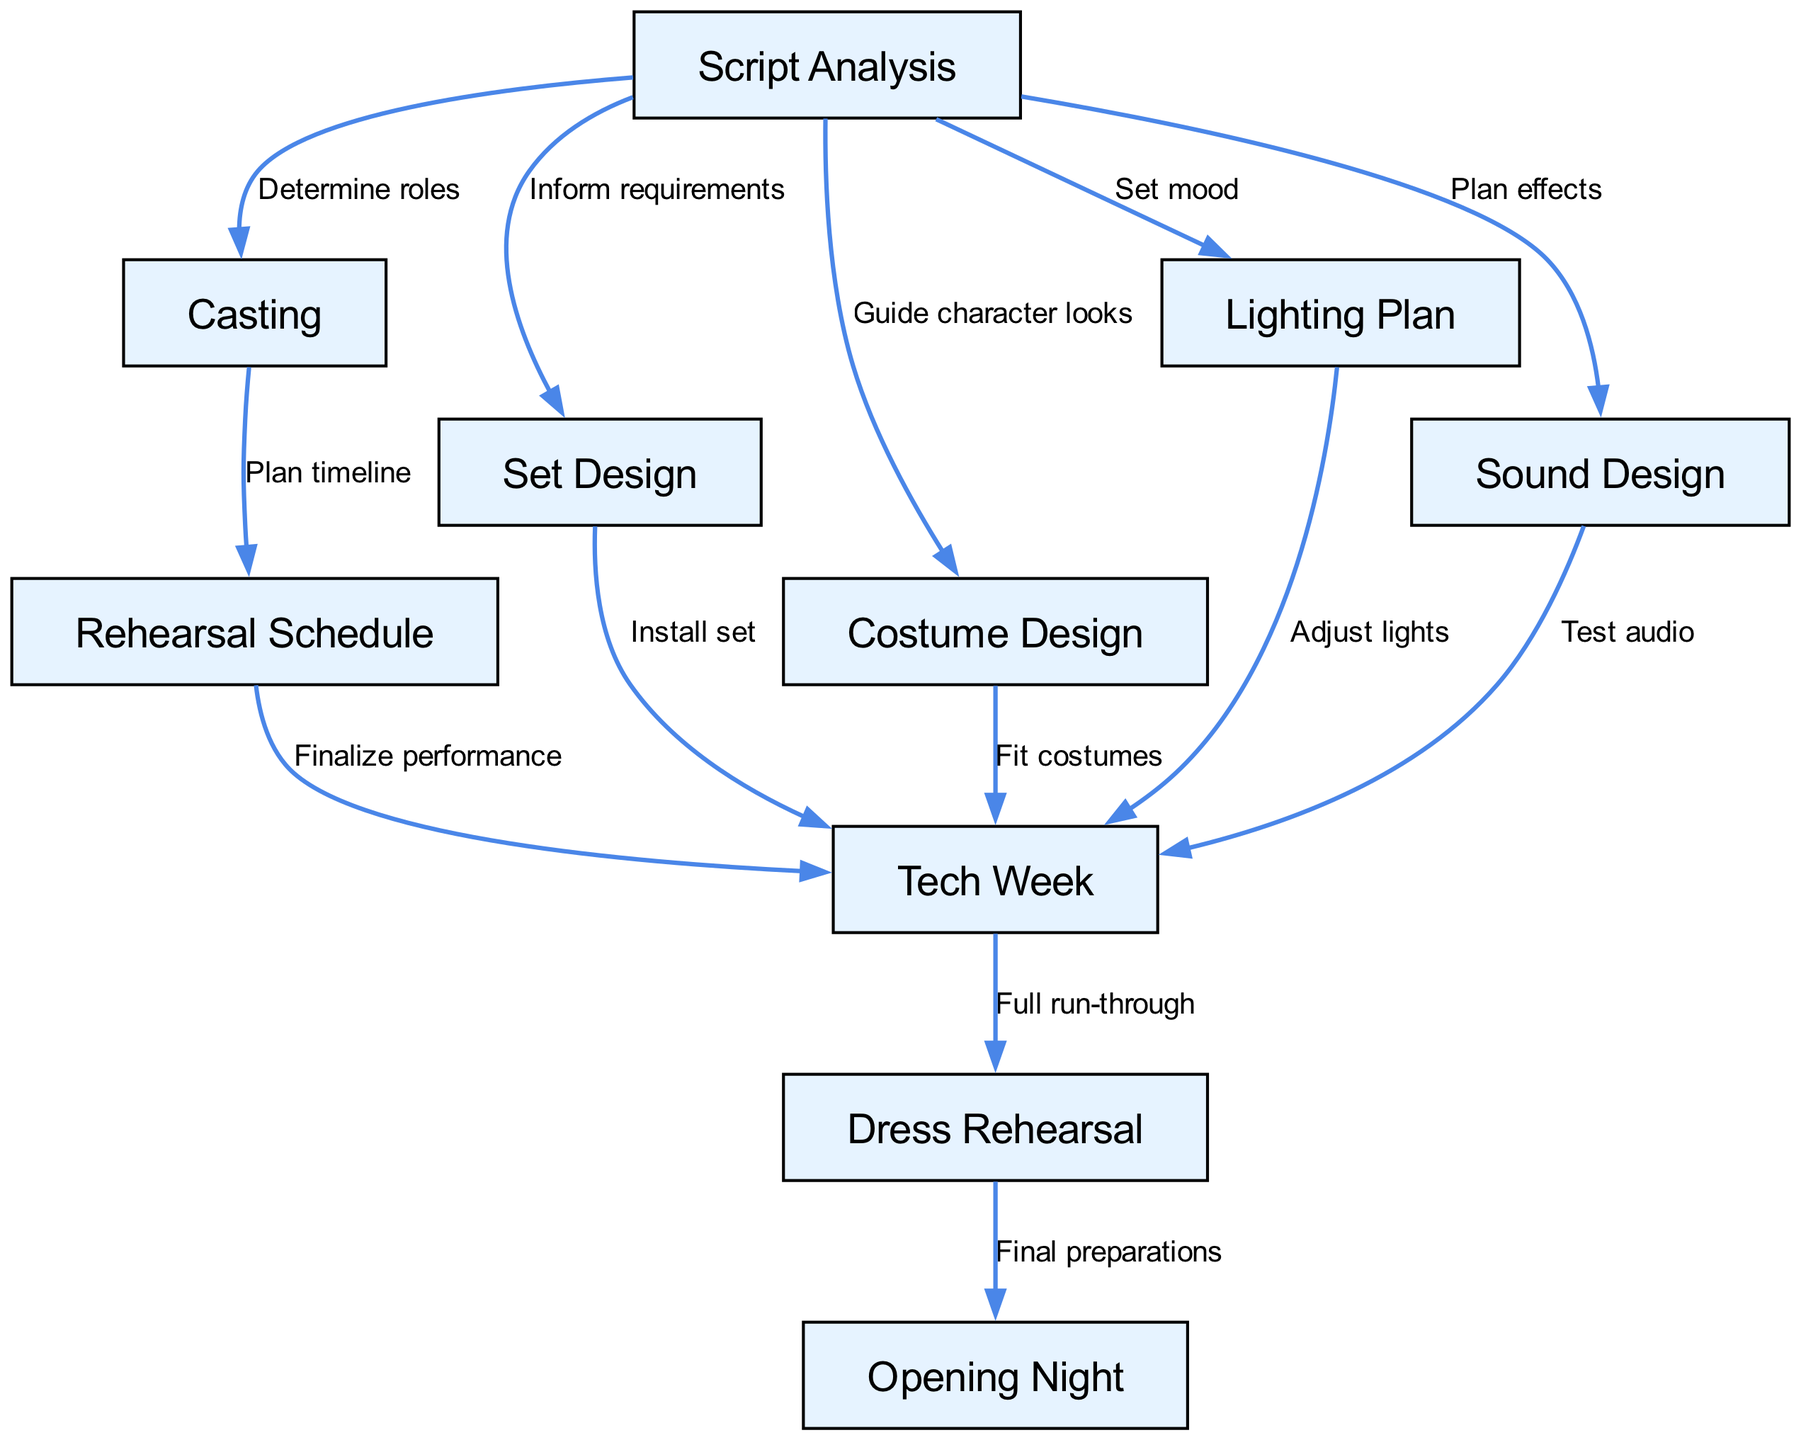What is the starting point of the flow? The starting point of the flow is "Script Analysis" as it does not have any incoming edges and is the first step in the process illustrated in the diagram.
Answer: Script Analysis How many nodes are there in the diagram? By counting all the unique points represented in the diagram, we find there are 10 nodes listed, each contributing to different aspects of the theater production process.
Answer: 10 What is the relationship between Casting and Rehearsal Schedule? The relationship is defined by the edge going from "Casting" to "Rehearsal Schedule", with the label "Plan timeline" indicating that casting informs the scheduling of rehearsals.
Answer: Plan timeline Which node directly follows Tech Week? The node that directly follows "Tech Week" in the flow of the process is "Dress Rehearsal", indicated by a directed edge leading to it after "Tech Week".
Answer: Dress Rehearsal What is the final step in the process? The final step in the flow of the theater production process is "Opening Night" which is the ultimate goal after all previous steps have been completed.
Answer: Opening Night How does Sound Design connect to Tech Week? "Sound Design" connects to "Tech Week" through the edge labeled "Test audio", indicating that audio testing happens during the tech week phase of production preparation.
Answer: Test audio Which two nodes follow Script Analysis? The two nodes that follow "Script Analysis" are "Casting" and "Set Design", which are linked by directed edges indicating steps that follow the analysis of the script.
Answer: Casting, Set Design What is the purpose of the edge from Dress Rehearsal to Opening Night? The purpose is indicated with the label "Final preparations," which signifies the transition from the rehearsal to the actual performance night preparations.
Answer: Final preparations How many edges are there in the diagram? Counting the connections represented between the nodes, we find there are 13 edges, which signify relationships and actions in the back stage flow of a theater production.
Answer: 13 